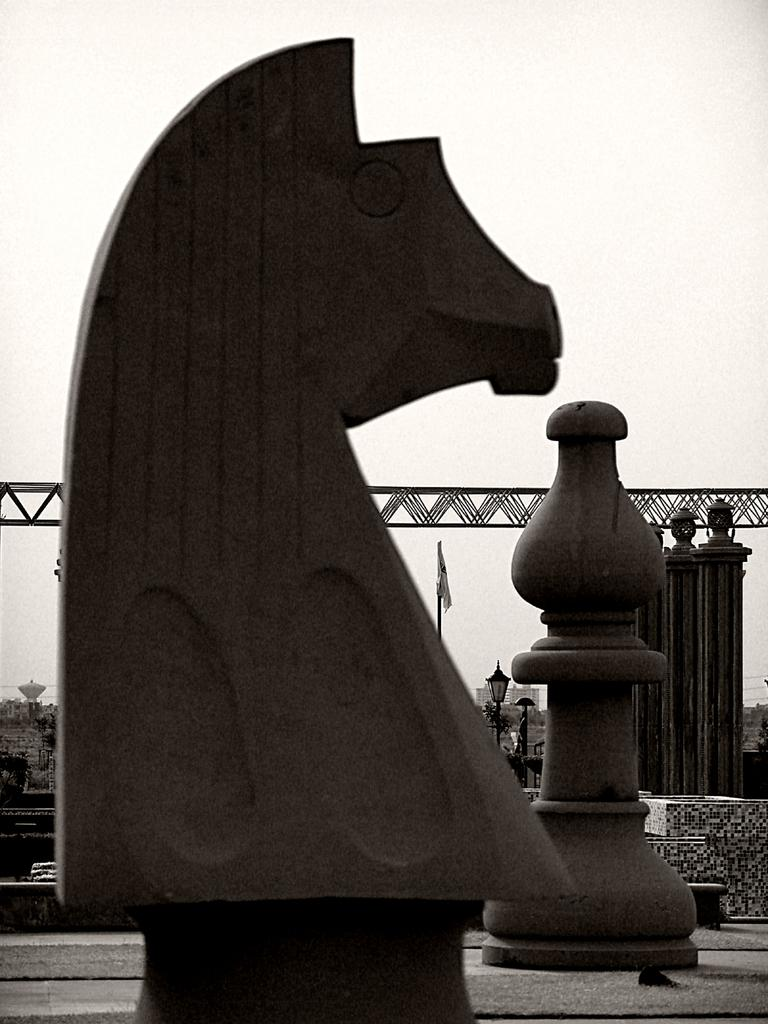What is the main subject of the image? There is a sculpture of chess coins in the image. What other objects can be seen in the image? There are poles with lamps and a pole with a flag in the image. What is visible in the background of the image? The sky is visible in the image. What shape is the chess theory in the image? There is no chess theory present in the image; it features a sculpture of chess coins. What level of difficulty is the sculpture on in the image? The image does not provide information about the difficulty level of the sculpture. 